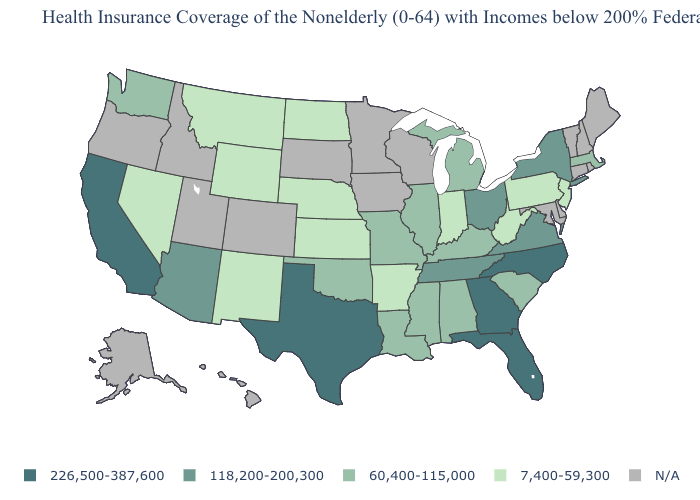Name the states that have a value in the range N/A?
Be succinct. Alaska, Colorado, Connecticut, Delaware, Hawaii, Idaho, Iowa, Maine, Maryland, Minnesota, New Hampshire, Oregon, Rhode Island, South Dakota, Utah, Vermont, Wisconsin. Among the states that border Indiana , does Michigan have the lowest value?
Short answer required. Yes. What is the highest value in states that border Louisiana?
Answer briefly. 226,500-387,600. Among the states that border Texas , which have the lowest value?
Answer briefly. Arkansas, New Mexico. How many symbols are there in the legend?
Concise answer only. 5. How many symbols are there in the legend?
Answer briefly. 5. What is the value of Pennsylvania?
Short answer required. 7,400-59,300. What is the value of New Mexico?
Answer briefly. 7,400-59,300. Name the states that have a value in the range 118,200-200,300?
Be succinct. Arizona, New York, Ohio, Tennessee, Virginia. What is the value of South Carolina?
Concise answer only. 60,400-115,000. What is the value of Alaska?
Answer briefly. N/A. Is the legend a continuous bar?
Keep it brief. No. What is the value of Wyoming?
Give a very brief answer. 7,400-59,300. What is the value of Oregon?
Answer briefly. N/A. 